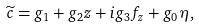<formula> <loc_0><loc_0><loc_500><loc_500>\widetilde { c } = g _ { 1 } + g _ { 2 } z + i g _ { 3 } f _ { z } + g _ { 0 } \eta ,</formula> 